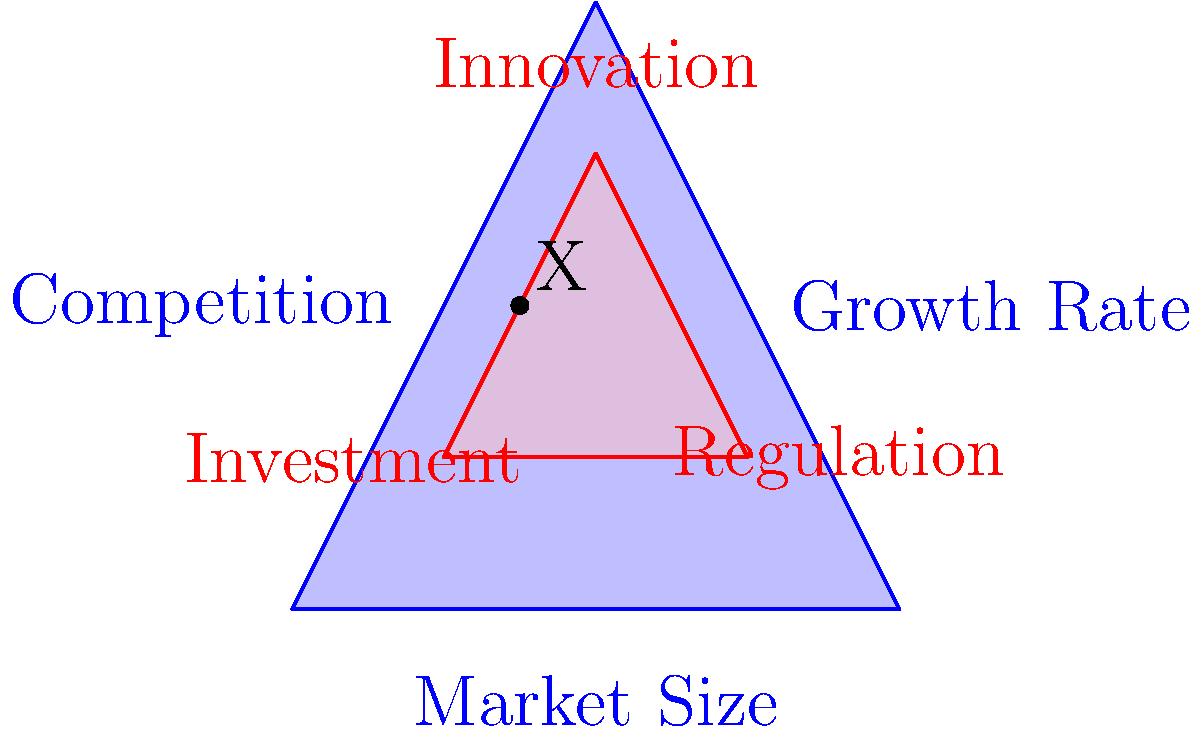In the diagram, two triangles represent interconnected market factors. The larger blue triangle represents primary market forces (Market Size, Growth Rate, and Competition), while the smaller red triangle represents secondary factors (Innovation, Investment, and Regulation). Point X is located at the midpoint of the line connecting "Investment" and "Innovation". Which primary market force does point X most closely align with, and what might this alignment suggest about the relationship between these factors in a data model? To solve this problem, we need to follow these steps:

1. Identify the position of point X:
   Point X is located at the midpoint between "Investment" and "Innovation" in the red triangle.

2. Analyze the relative position of X to the blue triangle:
   X appears to be closest to the "Market Size" vertex of the blue triangle.

3. Interpret the alignment:
   The proximity of X to "Market Size" suggests a strong relationship between Investment, Innovation, and Market Size in this model.

4. Consider the implications for a data model:
   This alignment implies that in our data model, we should expect:
   a) Investment and Innovation to have a significant impact on Market Size.
   b) Market Size to be a key driver or indicator for Investment and Innovation levels.
   c) A potential feedback loop where larger market size attracts more investment and drives innovation, which in turn may lead to further market growth.

5. Relate to mathematical modeling:
   In a mathematical representation, we might express this as:

   $$\text{Market Size} = f(\text{Investment}, \text{Innovation})$$

   Where $f$ is a function that describes how Investment and Innovation contribute to Market Size.

This spatial relationship provides insight into how these interconnected factors might be modeled and analyzed in a market trends data model.
Answer: Market Size; suggests strong influence of Investment and Innovation on Market Size and vice versa. 